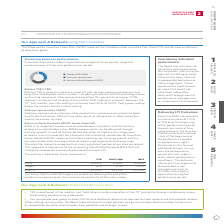According to Woolworths Limited's financial document, What does the lease-adjusted ROFE measure? Measures the balance between our earnings growth and the disciplined allocation and application of assets used to generate those earnings.. The document states: "g capabilities for the future. Lease‑adjusted ROFE measures the balance between our earnings growth and the disciplined allocation and application of ..." Also, What is the rTSR for Entry? According to the financial document, 16.66%. The relevant text states: "Entry 16.66% 6.66% 6.66% Target n/a 20% 20% Stretch 33.33% 33.33% 33.33%..." Also, What does the Sales per square metre measure? Measures sales productivity improvements across the Food and Drinks businesses.. The document states: "ales per square metre (SQM) Sales per square metre measures sales productivity improvements across the Food and Drinks businesses. Efficient use of ou..." Also, can you calculate: What is the total SALES/SQM for all 3 levels? Based on the calculation: 6.66% + 20% + 33.33% , the result is 59.99 (percentage). This is based on the information: "try 16.66% 6.66% 6.66% Target n/a 20% 20% Stretch 33.33% 33.33% 33.33% Entry 16.66% 6.66% 6.66% Target n/a 20% 20% Stretch 33.33% 33.33% 33.33% Entry 16.66% 6.66% 6.66% Target n/a 20% 20% Stretch 33.3..." The key data points involved are: 20, 33.33, 6.66. Also, can you calculate: What is the difference for rTSR between Stretch and Entry? Based on the calculation: 33.33% - 16.66% , the result is 16.67 (percentage). This is based on the information: "Entry 16.66% 6.66% 6.66% Target n/a 20% 20% Stretch 33.33% 33.33% 33.33% try 16.66% 6.66% 6.66% Target n/a 20% 20% Stretch 33.33% 33.33% 33.33%..." The key data points involved are: 16.66, 33.33. Also, can you calculate: What is the total ROFE across all 3 levels? Based on the calculation: 6.66% + 20% + 33.33% , the result is 59.99 (percentage). This is based on the information: "try 16.66% 6.66% 6.66% Target n/a 20% 20% Stretch 33.33% 33.33% 33.33% Entry 16.66% 6.66% 6.66% Target n/a 20% 20% Stretch 33.33% 33.33% 33.33% Entry 16.66% 6.66% 6.66% Target n/a 20% 20% Stretch 33.3..." The key data points involved are: 20, 33.33, 6.66. 